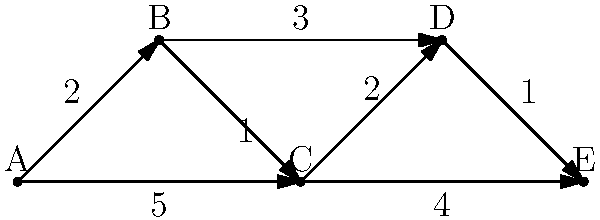In the graph above, each vertex represents an airport, and each edge represents a flight route with its associated flight time (in hours). As a computer engineer with virtual flying experience, determine the shortest path from airport A to airport E, and calculate the total flight time for this route. To find the shortest path from A to E, we'll use Dijkstra's algorithm, which is commonly used in flight simulators for route planning:

1) Initialize:
   - Distance to A: 0
   - Distance to all other nodes: infinity
   - Previous node for all: undefined
   - Unvisited set: {A, B, C, D, E}

2) From A:
   - A to B: 2 hours
   - A to C: 5 hours
   - Select B (shorter distance)

3) From B:
   - B to C: 2 + 1 = 3 hours (update C)
   - B to D: 2 + 3 = 5 hours
   - Select C (shorter distance)

4) From C:
   - C to D: 3 + 2 = 5 hours
   - C to E: 3 + 4 = 7 hours
   - Select D (shorter distance)

5) From D:
   - D to E: 5 + 1 = 6 hours (update E)
   - Select E (only remaining node)

6) Algorithm complete. Shortest path: A → B → C → D → E

The total flight time for this route is 6 hours.
Answer: A → B → C → D → E, 6 hours 